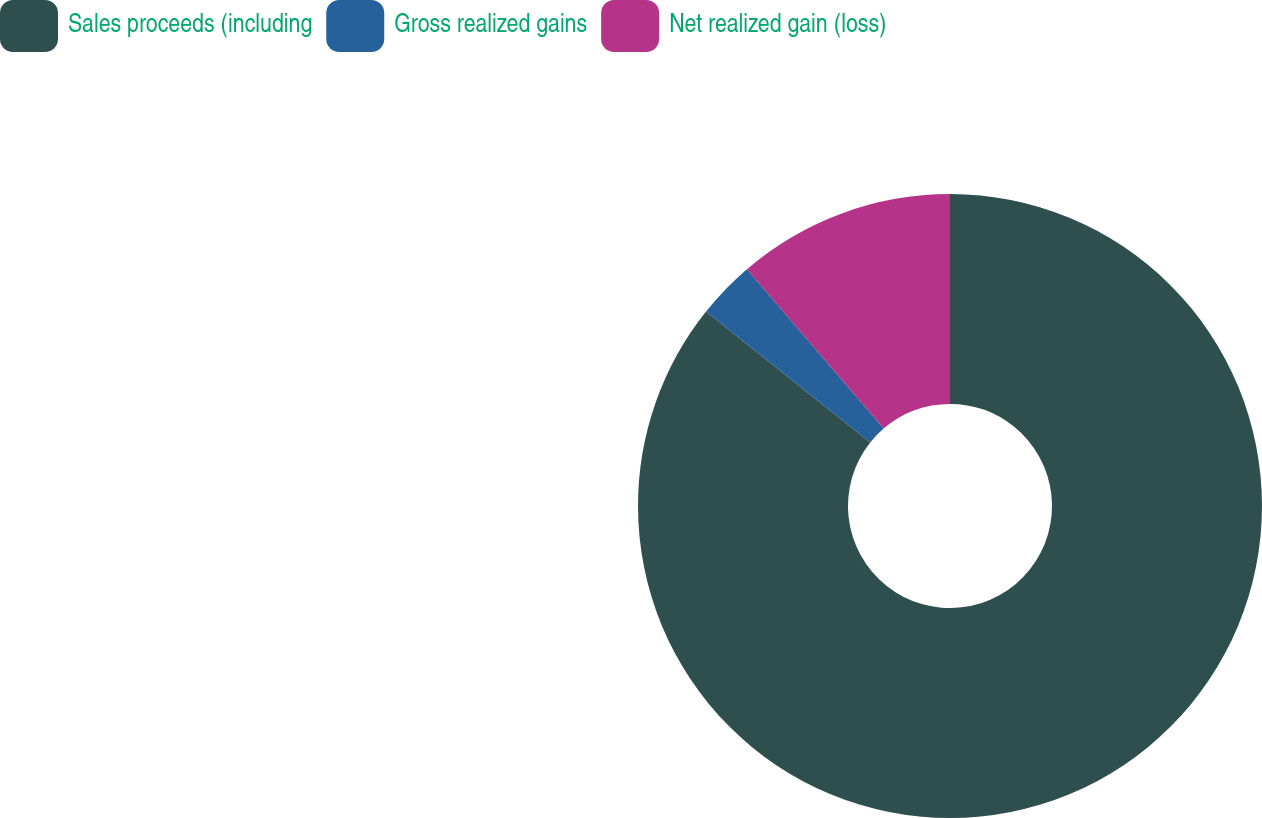Convert chart. <chart><loc_0><loc_0><loc_500><loc_500><pie_chart><fcel>Sales proceeds (including<fcel>Gross realized gains<fcel>Net realized gain (loss)<nl><fcel>85.71%<fcel>3.01%<fcel>11.28%<nl></chart> 